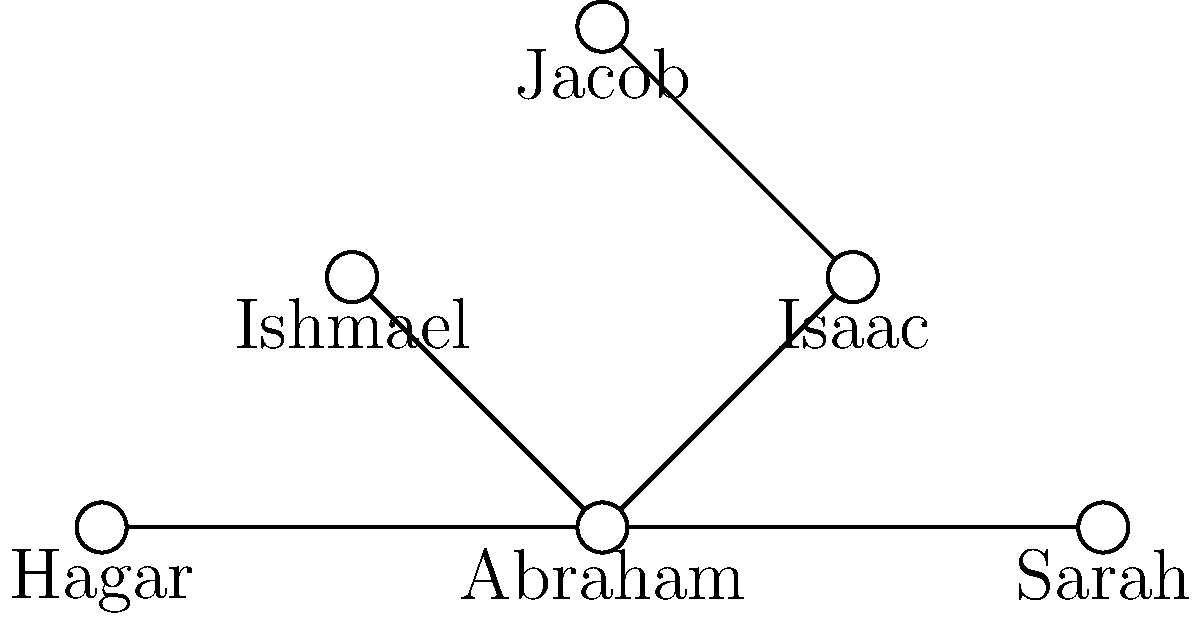Based on the network diagram of biblical figures, who are the two wives of Abraham shown, and which one is the mother of Isaac? To answer this question, let's analyze the network diagram step by step:

1. We can see that Abraham is at the center of the network, connected to several other figures.

2. There are two women directly connected to Abraham: Sarah and Hagar. These represent his two wives according to the biblical narrative.

3. We need to determine which of these two women is the mother of Isaac. To do this, we should look at the connections from Isaac.

4. We can see that Isaac is directly connected to Abraham, indicating that Abraham is his father.

5. However, Isaac is not directly connected to either Sarah or Hagar in this diagram.

6. In biblical history, we know that Sarah is the mother of Isaac. This is a key part of the narrative, as Sarah was initially barren and bore Isaac in her old age as a fulfillment of God's promise.

7. Hagar, on the other hand, is the mother of Ishmael, which we can see represented in the diagram by the connection between Abraham and Ishmael.

Therefore, while both Sarah and Hagar are shown as wives of Abraham, Sarah is the mother of Isaac according to biblical tradition.
Answer: Sarah and Hagar; Sarah 